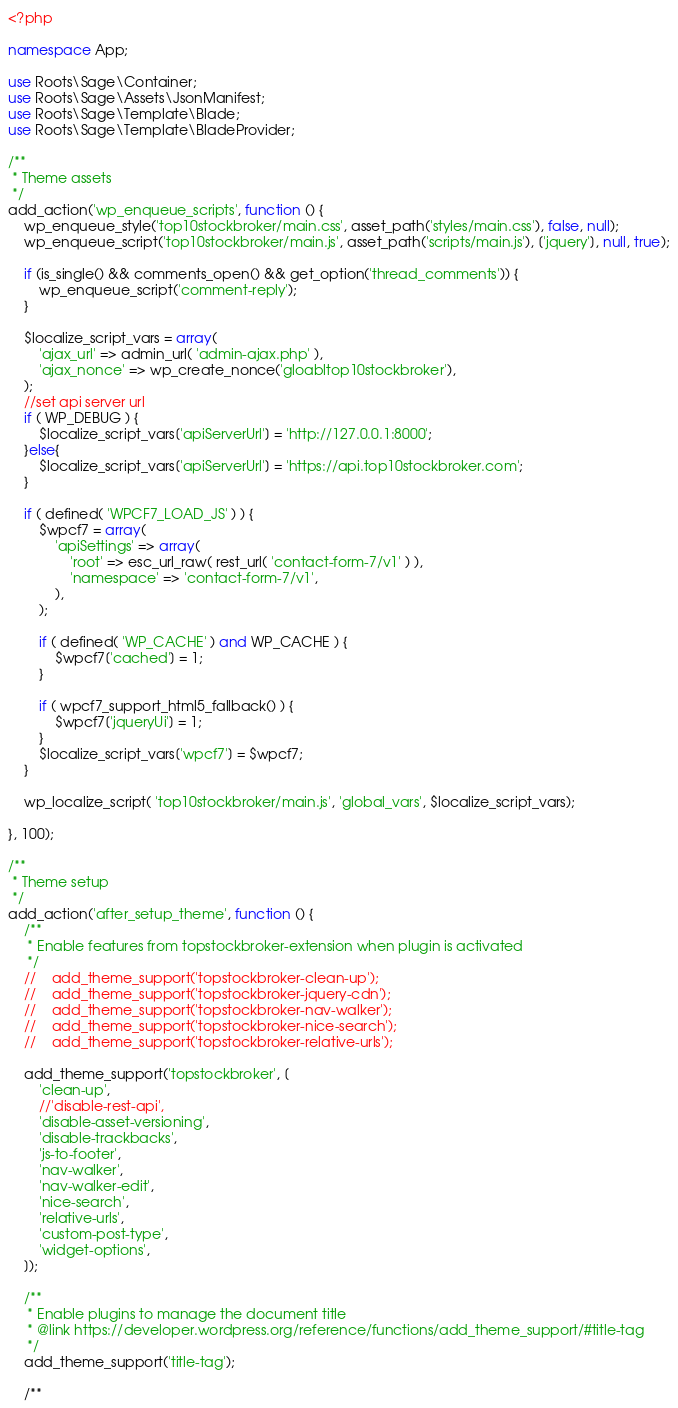Convert code to text. <code><loc_0><loc_0><loc_500><loc_500><_PHP_><?php

namespace App;

use Roots\Sage\Container;
use Roots\Sage\Assets\JsonManifest;
use Roots\Sage\Template\Blade;
use Roots\Sage\Template\BladeProvider;

/**
 * Theme assets
 */
add_action('wp_enqueue_scripts', function () {
    wp_enqueue_style('top10stockbroker/main.css', asset_path('styles/main.css'), false, null);
    wp_enqueue_script('top10stockbroker/main.js', asset_path('scripts/main.js'), ['jquery'], null, true);

    if (is_single() && comments_open() && get_option('thread_comments')) {
        wp_enqueue_script('comment-reply');
    }

    $localize_script_vars = array( 
        'ajax_url' => admin_url( 'admin-ajax.php' ),
        'ajax_nonce' => wp_create_nonce('gloabltop10stockbroker'),
    );
    //set api server url
    if ( WP_DEBUG ) {
        $localize_script_vars['apiServerUrl'] = 'http://127.0.0.1:8000';
    }else{
        $localize_script_vars['apiServerUrl'] = 'https://api.top10stockbroker.com';
    }

    if ( defined( 'WPCF7_LOAD_JS' ) ) {
        $wpcf7 = array(
            'apiSettings' => array(
                'root' => esc_url_raw( rest_url( 'contact-form-7/v1' ) ),
                'namespace' => 'contact-form-7/v1',
            ),
        );

        if ( defined( 'WP_CACHE' ) and WP_CACHE ) {
            $wpcf7['cached'] = 1;
        }

        if ( wpcf7_support_html5_fallback() ) {
            $wpcf7['jqueryUi'] = 1;
        }
        $localize_script_vars['wpcf7'] = $wpcf7;
    }

    wp_localize_script( 'top10stockbroker/main.js', 'global_vars', $localize_script_vars);

}, 100);

/**
 * Theme setup
 */
add_action('after_setup_theme', function () {
    /**
     * Enable features from topstockbroker-extension when plugin is activated
     */
    //    add_theme_support('topstockbroker-clean-up');
    //    add_theme_support('topstockbroker-jquery-cdn');
    //    add_theme_support('topstockbroker-nav-walker');
    //    add_theme_support('topstockbroker-nice-search');
    //    add_theme_support('topstockbroker-relative-urls');

    add_theme_support('topstockbroker', [
        'clean-up',
        //'disable-rest-api',
        'disable-asset-versioning',
        'disable-trackbacks',
        'js-to-footer',
        'nav-walker',
        'nav-walker-edit',
        'nice-search',
        'relative-urls',
        'custom-post-type',
        'widget-options',
    ]);

    /**
     * Enable plugins to manage the document title
     * @link https://developer.wordpress.org/reference/functions/add_theme_support/#title-tag
     */
    add_theme_support('title-tag');

    /**</code> 